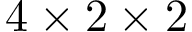<formula> <loc_0><loc_0><loc_500><loc_500>4 \times 2 \times 2</formula> 